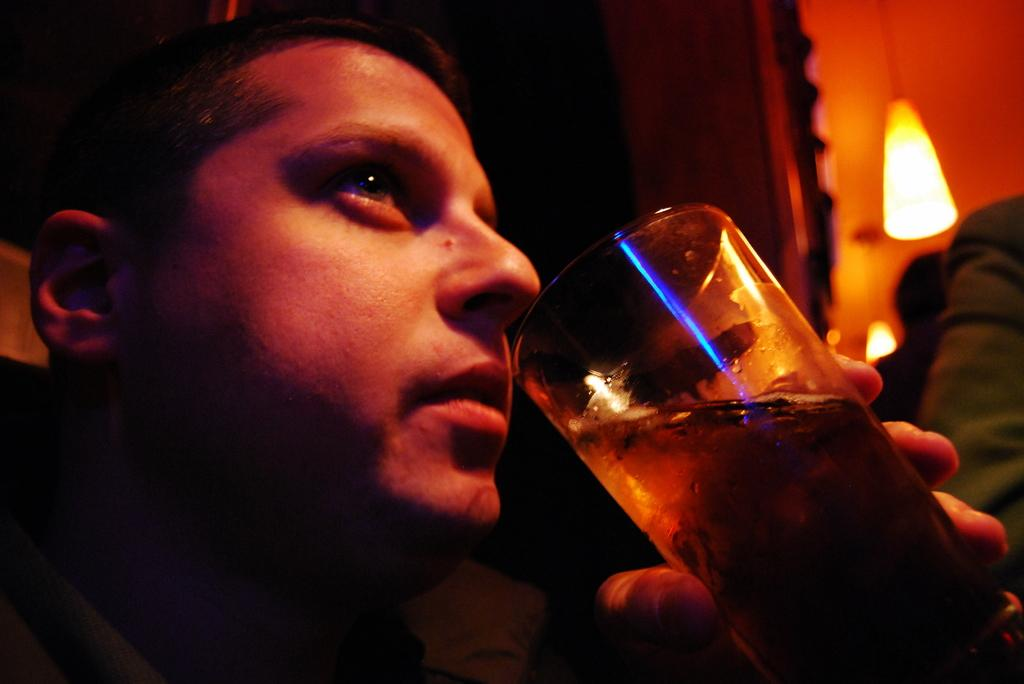Who is the main subject in the foreground of the image? There is a man in the foreground of the image. What is the man holding in the image? The man is holding a glass. How would you describe the lighting in the background of the image? The background of the image is dark, but there is a light hanging from the ceiling. Can you describe the people in the background of the image? There are two persons in the background. What type of spoon is being used to reach an agreement between the two persons in the image? There is no spoon present in the image, and no agreement is being made between the two persons in the background. --- Facts: 1. There is a car in the image. 2. The car is red. 3. The car has four wheels. 4. There is a road in the image. 5. The road is paved. Absurd Topics: bird, ocean, mountain Conversation: What is the main subject in the image? The main subject in the image is a car. What color is the car? The car is red. How many wheels does the car have? The car has four wheels. What type of surface is the car on in the image? There is a road in the image, and it is paved. Reasoning: Let's think step by step in order to produce the conversation. We start by identifying the main subject in the image, which is the car. Then, we describe the car's color and the number of wheels it has. Next, we focus on the car's surroundings, mentioning the presence of a road and its paved surface. Absurd Question/Answer: Can you see any birds flying over the ocean near the mountain in the image? There are no birds, ocean, or mountains present in the image; it only features a red car on a paved road. 